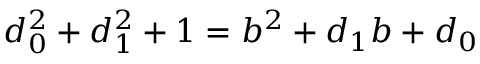Convert formula to latex. <formula><loc_0><loc_0><loc_500><loc_500>d _ { 0 } ^ { 2 } + d _ { 1 } ^ { 2 } + 1 = b ^ { 2 } + d _ { 1 } b + d _ { 0 }</formula> 